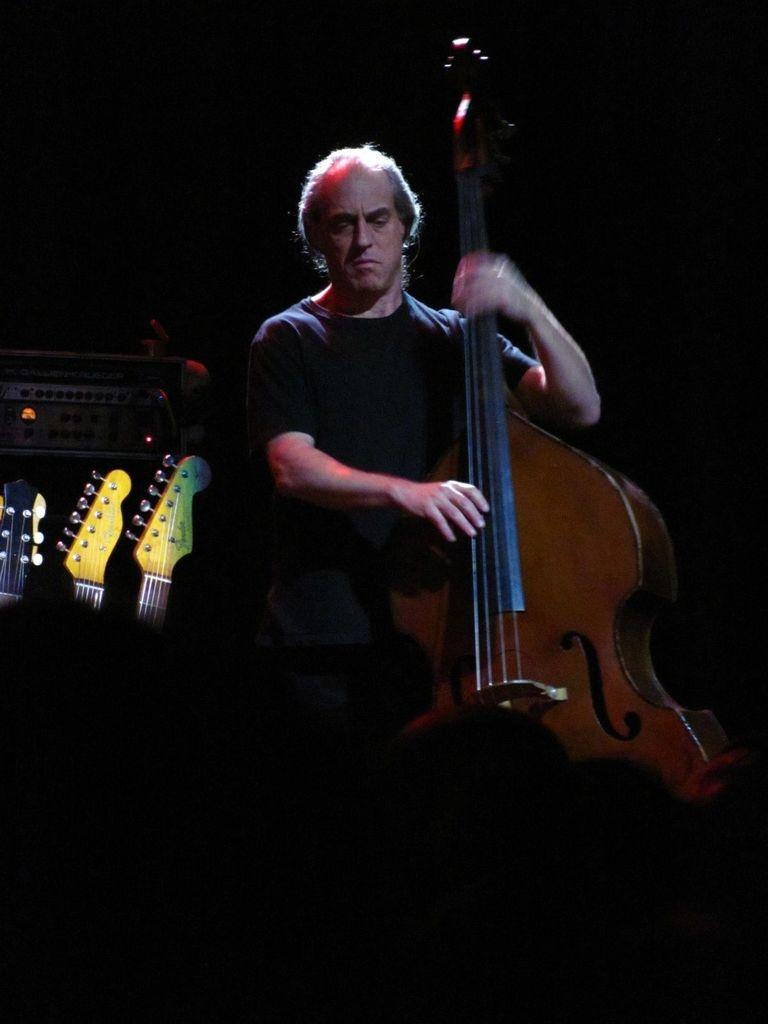Who or what is the main subject in the image? There is a person in the image. What can be observed about the background in the image? The person is on a dark background. What is the person wearing in the image? The person is wearing clothes. What activity is the person engaged in? The person is playing a musical instrument. Where are the musical instruments located in the image? There are musical instruments on the left side of the image. Can you see the moon in the image? No, the moon is not present in the image. Is the person driving a vehicle in the image? No, the person is not driving a vehicle in the image; they are playing a musical instrument. 